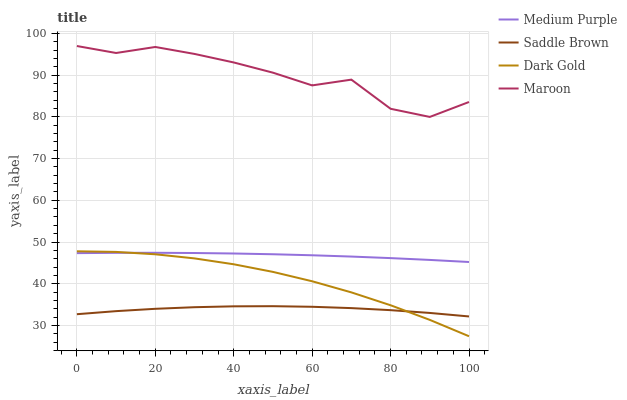Does Saddle Brown have the minimum area under the curve?
Answer yes or no. Yes. Does Maroon have the maximum area under the curve?
Answer yes or no. Yes. Does Maroon have the minimum area under the curve?
Answer yes or no. No. Does Saddle Brown have the maximum area under the curve?
Answer yes or no. No. Is Medium Purple the smoothest?
Answer yes or no. Yes. Is Maroon the roughest?
Answer yes or no. Yes. Is Saddle Brown the smoothest?
Answer yes or no. No. Is Saddle Brown the roughest?
Answer yes or no. No. Does Dark Gold have the lowest value?
Answer yes or no. Yes. Does Saddle Brown have the lowest value?
Answer yes or no. No. Does Maroon have the highest value?
Answer yes or no. Yes. Does Saddle Brown have the highest value?
Answer yes or no. No. Is Saddle Brown less than Maroon?
Answer yes or no. Yes. Is Medium Purple greater than Saddle Brown?
Answer yes or no. Yes. Does Dark Gold intersect Saddle Brown?
Answer yes or no. Yes. Is Dark Gold less than Saddle Brown?
Answer yes or no. No. Is Dark Gold greater than Saddle Brown?
Answer yes or no. No. Does Saddle Brown intersect Maroon?
Answer yes or no. No. 